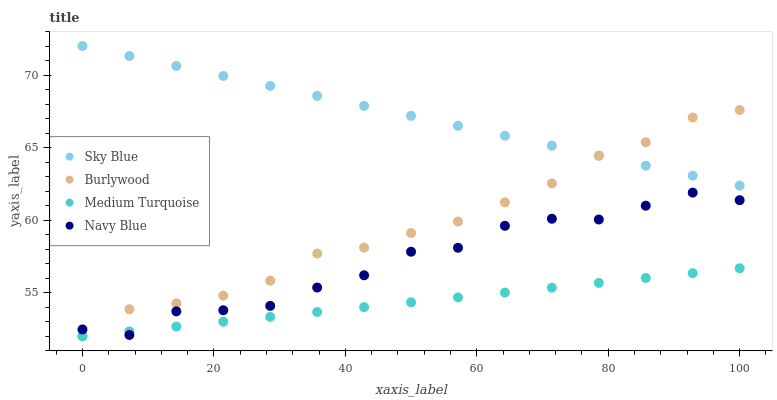Does Medium Turquoise have the minimum area under the curve?
Answer yes or no. Yes. Does Sky Blue have the maximum area under the curve?
Answer yes or no. Yes. Does Sky Blue have the minimum area under the curve?
Answer yes or no. No. Does Medium Turquoise have the maximum area under the curve?
Answer yes or no. No. Is Medium Turquoise the smoothest?
Answer yes or no. Yes. Is Navy Blue the roughest?
Answer yes or no. Yes. Is Sky Blue the smoothest?
Answer yes or no. No. Is Sky Blue the roughest?
Answer yes or no. No. Does Burlywood have the lowest value?
Answer yes or no. Yes. Does Sky Blue have the lowest value?
Answer yes or no. No. Does Sky Blue have the highest value?
Answer yes or no. Yes. Does Medium Turquoise have the highest value?
Answer yes or no. No. Is Navy Blue less than Sky Blue?
Answer yes or no. Yes. Is Sky Blue greater than Medium Turquoise?
Answer yes or no. Yes. Does Navy Blue intersect Burlywood?
Answer yes or no. Yes. Is Navy Blue less than Burlywood?
Answer yes or no. No. Is Navy Blue greater than Burlywood?
Answer yes or no. No. Does Navy Blue intersect Sky Blue?
Answer yes or no. No. 